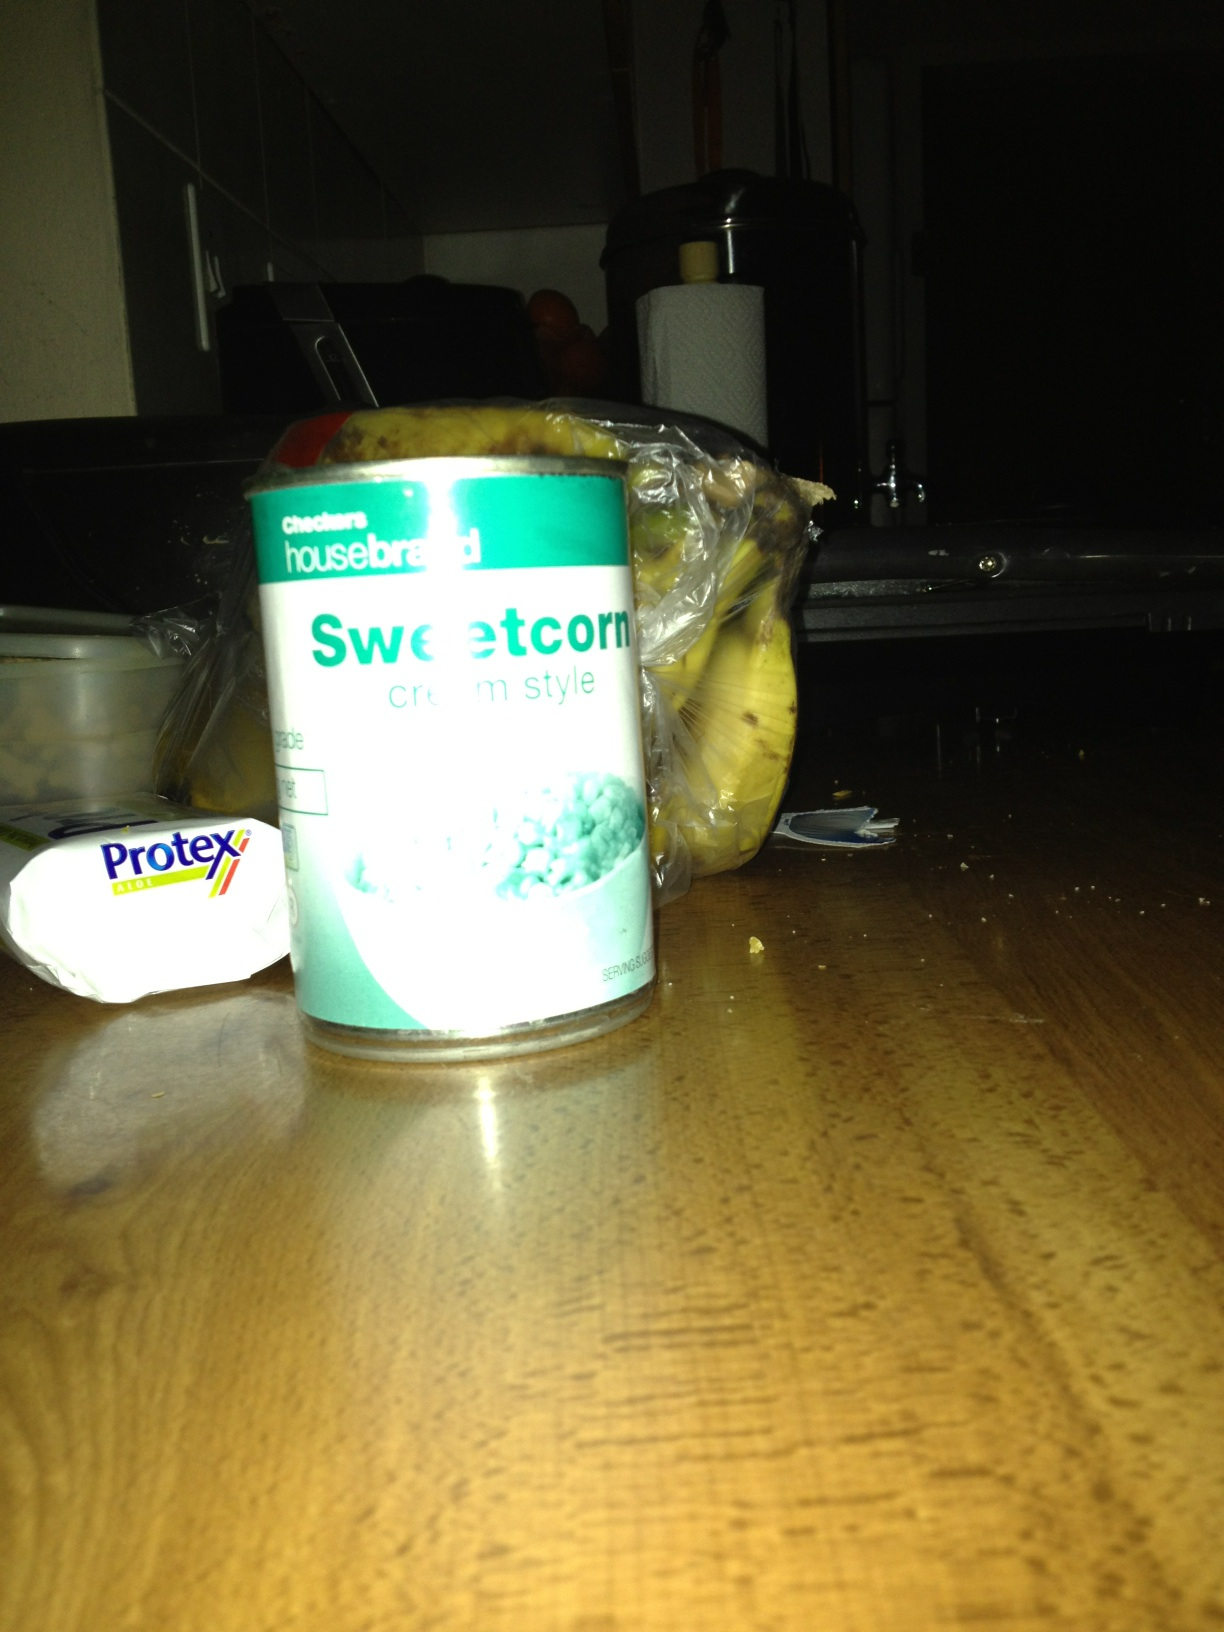Can you tell me more about the sweetcorn in the can? Certainly! This is a can of sweetcorn, a popular vegetable that is often used in soups, salads, and as a side dish. The label specifies that this is the 'cream style' variety, which typically means the kernels are blended with a creamy base, making it thicker and more suitable for certain recipes. 